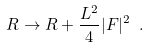<formula> <loc_0><loc_0><loc_500><loc_500>R \rightarrow R + \frac { L ^ { 2 } } { 4 } | F | ^ { 2 } \ .</formula> 